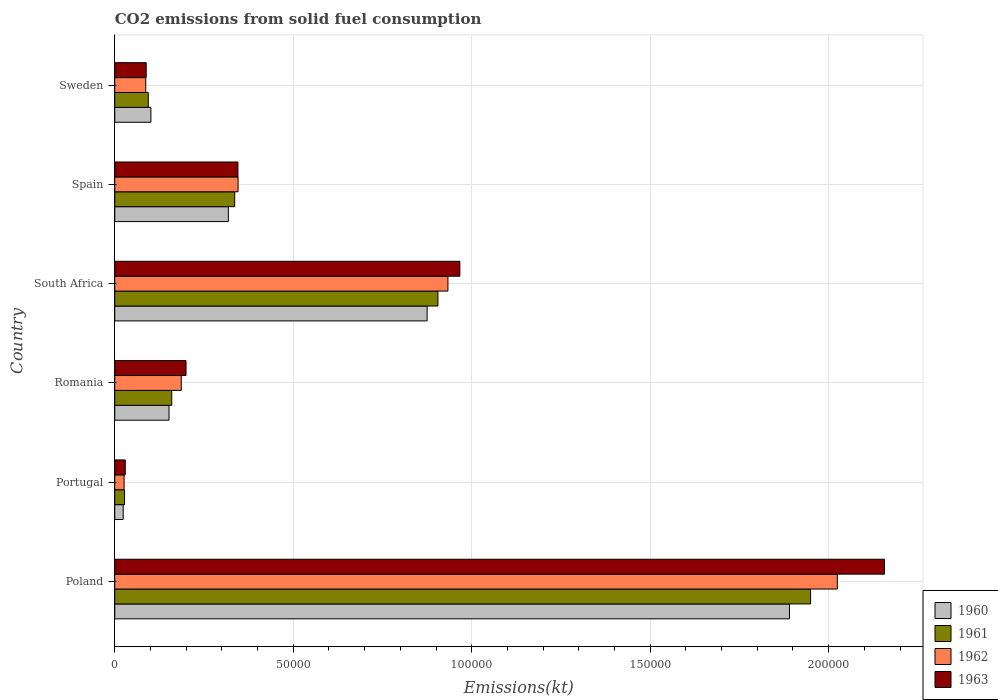How many different coloured bars are there?
Your answer should be very brief. 4. Are the number of bars per tick equal to the number of legend labels?
Make the answer very short. Yes. Are the number of bars on each tick of the Y-axis equal?
Your answer should be compact. Yes. In how many cases, is the number of bars for a given country not equal to the number of legend labels?
Your response must be concise. 0. What is the amount of CO2 emitted in 1963 in South Africa?
Your answer should be very brief. 9.67e+04. Across all countries, what is the maximum amount of CO2 emitted in 1963?
Your answer should be very brief. 2.16e+05. Across all countries, what is the minimum amount of CO2 emitted in 1961?
Make the answer very short. 2742.92. What is the total amount of CO2 emitted in 1963 in the graph?
Ensure brevity in your answer.  3.79e+05. What is the difference between the amount of CO2 emitted in 1960 in Romania and that in South Africa?
Provide a succinct answer. -7.23e+04. What is the difference between the amount of CO2 emitted in 1960 in Portugal and the amount of CO2 emitted in 1961 in Sweden?
Your answer should be very brief. -7029.64. What is the average amount of CO2 emitted in 1963 per country?
Your response must be concise. 6.31e+04. What is the difference between the amount of CO2 emitted in 1961 and amount of CO2 emitted in 1963 in Portugal?
Provide a succinct answer. -201.68. In how many countries, is the amount of CO2 emitted in 1961 greater than 50000 kt?
Offer a terse response. 2. What is the ratio of the amount of CO2 emitted in 1960 in Romania to that in South Africa?
Your answer should be compact. 0.17. Is the difference between the amount of CO2 emitted in 1961 in Portugal and Romania greater than the difference between the amount of CO2 emitted in 1963 in Portugal and Romania?
Your answer should be compact. Yes. What is the difference between the highest and the second highest amount of CO2 emitted in 1963?
Offer a terse response. 1.19e+05. What is the difference between the highest and the lowest amount of CO2 emitted in 1962?
Your answer should be very brief. 2.00e+05. In how many countries, is the amount of CO2 emitted in 1960 greater than the average amount of CO2 emitted in 1960 taken over all countries?
Provide a succinct answer. 2. What does the 2nd bar from the top in South Africa represents?
Keep it short and to the point. 1962. How many bars are there?
Make the answer very short. 24. How many countries are there in the graph?
Make the answer very short. 6. Are the values on the major ticks of X-axis written in scientific E-notation?
Make the answer very short. No. Does the graph contain grids?
Ensure brevity in your answer.  Yes. How many legend labels are there?
Keep it short and to the point. 4. What is the title of the graph?
Provide a succinct answer. CO2 emissions from solid fuel consumption. Does "1986" appear as one of the legend labels in the graph?
Your answer should be compact. No. What is the label or title of the X-axis?
Provide a succinct answer. Emissions(kt). What is the label or title of the Y-axis?
Offer a terse response. Country. What is the Emissions(kt) of 1960 in Poland?
Your answer should be compact. 1.89e+05. What is the Emissions(kt) of 1961 in Poland?
Keep it short and to the point. 1.95e+05. What is the Emissions(kt) in 1962 in Poland?
Make the answer very short. 2.02e+05. What is the Emissions(kt) of 1963 in Poland?
Make the answer very short. 2.16e+05. What is the Emissions(kt) in 1960 in Portugal?
Give a very brief answer. 2365.22. What is the Emissions(kt) of 1961 in Portugal?
Make the answer very short. 2742.92. What is the Emissions(kt) of 1962 in Portugal?
Offer a terse response. 2610.9. What is the Emissions(kt) of 1963 in Portugal?
Offer a terse response. 2944.6. What is the Emissions(kt) of 1960 in Romania?
Make the answer very short. 1.52e+04. What is the Emissions(kt) in 1961 in Romania?
Your answer should be very brief. 1.60e+04. What is the Emissions(kt) of 1962 in Romania?
Your answer should be compact. 1.86e+04. What is the Emissions(kt) of 1963 in Romania?
Keep it short and to the point. 2.00e+04. What is the Emissions(kt) of 1960 in South Africa?
Ensure brevity in your answer.  8.75e+04. What is the Emissions(kt) of 1961 in South Africa?
Your answer should be very brief. 9.05e+04. What is the Emissions(kt) of 1962 in South Africa?
Your answer should be very brief. 9.33e+04. What is the Emissions(kt) of 1963 in South Africa?
Your answer should be very brief. 9.67e+04. What is the Emissions(kt) of 1960 in Spain?
Keep it short and to the point. 3.18e+04. What is the Emissions(kt) of 1961 in Spain?
Offer a terse response. 3.36e+04. What is the Emissions(kt) in 1962 in Spain?
Offer a very short reply. 3.45e+04. What is the Emissions(kt) in 1963 in Spain?
Make the answer very short. 3.45e+04. What is the Emissions(kt) of 1960 in Sweden?
Offer a terse response. 1.01e+04. What is the Emissions(kt) of 1961 in Sweden?
Your response must be concise. 9394.85. What is the Emissions(kt) of 1962 in Sweden?
Give a very brief answer. 8683.46. What is the Emissions(kt) in 1963 in Sweden?
Your response must be concise. 8808.13. Across all countries, what is the maximum Emissions(kt) in 1960?
Provide a succinct answer. 1.89e+05. Across all countries, what is the maximum Emissions(kt) of 1961?
Your answer should be compact. 1.95e+05. Across all countries, what is the maximum Emissions(kt) in 1962?
Ensure brevity in your answer.  2.02e+05. Across all countries, what is the maximum Emissions(kt) in 1963?
Keep it short and to the point. 2.16e+05. Across all countries, what is the minimum Emissions(kt) of 1960?
Keep it short and to the point. 2365.22. Across all countries, what is the minimum Emissions(kt) of 1961?
Give a very brief answer. 2742.92. Across all countries, what is the minimum Emissions(kt) of 1962?
Your answer should be compact. 2610.9. Across all countries, what is the minimum Emissions(kt) in 1963?
Keep it short and to the point. 2944.6. What is the total Emissions(kt) of 1960 in the graph?
Provide a succinct answer. 3.36e+05. What is the total Emissions(kt) in 1961 in the graph?
Give a very brief answer. 3.47e+05. What is the total Emissions(kt) of 1962 in the graph?
Your answer should be compact. 3.60e+05. What is the total Emissions(kt) of 1963 in the graph?
Offer a terse response. 3.79e+05. What is the difference between the Emissions(kt) in 1960 in Poland and that in Portugal?
Make the answer very short. 1.87e+05. What is the difference between the Emissions(kt) of 1961 in Poland and that in Portugal?
Your response must be concise. 1.92e+05. What is the difference between the Emissions(kt) of 1962 in Poland and that in Portugal?
Give a very brief answer. 2.00e+05. What is the difference between the Emissions(kt) in 1963 in Poland and that in Portugal?
Keep it short and to the point. 2.13e+05. What is the difference between the Emissions(kt) of 1960 in Poland and that in Romania?
Provide a short and direct response. 1.74e+05. What is the difference between the Emissions(kt) of 1961 in Poland and that in Romania?
Offer a terse response. 1.79e+05. What is the difference between the Emissions(kt) in 1962 in Poland and that in Romania?
Offer a very short reply. 1.84e+05. What is the difference between the Emissions(kt) in 1963 in Poland and that in Romania?
Offer a terse response. 1.96e+05. What is the difference between the Emissions(kt) in 1960 in Poland and that in South Africa?
Your answer should be compact. 1.02e+05. What is the difference between the Emissions(kt) of 1961 in Poland and that in South Africa?
Provide a short and direct response. 1.04e+05. What is the difference between the Emissions(kt) of 1962 in Poland and that in South Africa?
Your answer should be compact. 1.09e+05. What is the difference between the Emissions(kt) in 1963 in Poland and that in South Africa?
Provide a short and direct response. 1.19e+05. What is the difference between the Emissions(kt) in 1960 in Poland and that in Spain?
Provide a short and direct response. 1.57e+05. What is the difference between the Emissions(kt) in 1961 in Poland and that in Spain?
Offer a very short reply. 1.61e+05. What is the difference between the Emissions(kt) of 1962 in Poland and that in Spain?
Ensure brevity in your answer.  1.68e+05. What is the difference between the Emissions(kt) of 1963 in Poland and that in Spain?
Ensure brevity in your answer.  1.81e+05. What is the difference between the Emissions(kt) of 1960 in Poland and that in Sweden?
Give a very brief answer. 1.79e+05. What is the difference between the Emissions(kt) of 1961 in Poland and that in Sweden?
Provide a succinct answer. 1.86e+05. What is the difference between the Emissions(kt) in 1962 in Poland and that in Sweden?
Offer a terse response. 1.94e+05. What is the difference between the Emissions(kt) in 1963 in Poland and that in Sweden?
Keep it short and to the point. 2.07e+05. What is the difference between the Emissions(kt) in 1960 in Portugal and that in Romania?
Keep it short and to the point. -1.28e+04. What is the difference between the Emissions(kt) of 1961 in Portugal and that in Romania?
Keep it short and to the point. -1.32e+04. What is the difference between the Emissions(kt) in 1962 in Portugal and that in Romania?
Make the answer very short. -1.60e+04. What is the difference between the Emissions(kt) of 1963 in Portugal and that in Romania?
Your answer should be very brief. -1.70e+04. What is the difference between the Emissions(kt) in 1960 in Portugal and that in South Africa?
Give a very brief answer. -8.51e+04. What is the difference between the Emissions(kt) of 1961 in Portugal and that in South Africa?
Give a very brief answer. -8.78e+04. What is the difference between the Emissions(kt) of 1962 in Portugal and that in South Africa?
Give a very brief answer. -9.07e+04. What is the difference between the Emissions(kt) of 1963 in Portugal and that in South Africa?
Provide a succinct answer. -9.37e+04. What is the difference between the Emissions(kt) in 1960 in Portugal and that in Spain?
Offer a very short reply. -2.95e+04. What is the difference between the Emissions(kt) in 1961 in Portugal and that in Spain?
Keep it short and to the point. -3.09e+04. What is the difference between the Emissions(kt) in 1962 in Portugal and that in Spain?
Ensure brevity in your answer.  -3.19e+04. What is the difference between the Emissions(kt) in 1963 in Portugal and that in Spain?
Provide a short and direct response. -3.16e+04. What is the difference between the Emissions(kt) in 1960 in Portugal and that in Sweden?
Your response must be concise. -7759.37. What is the difference between the Emissions(kt) in 1961 in Portugal and that in Sweden?
Offer a very short reply. -6651.94. What is the difference between the Emissions(kt) in 1962 in Portugal and that in Sweden?
Your response must be concise. -6072.55. What is the difference between the Emissions(kt) in 1963 in Portugal and that in Sweden?
Ensure brevity in your answer.  -5863.53. What is the difference between the Emissions(kt) in 1960 in Romania and that in South Africa?
Keep it short and to the point. -7.23e+04. What is the difference between the Emissions(kt) in 1961 in Romania and that in South Africa?
Your answer should be compact. -7.46e+04. What is the difference between the Emissions(kt) in 1962 in Romania and that in South Africa?
Offer a very short reply. -7.47e+04. What is the difference between the Emissions(kt) of 1963 in Romania and that in South Africa?
Provide a succinct answer. -7.67e+04. What is the difference between the Emissions(kt) of 1960 in Romania and that in Spain?
Keep it short and to the point. -1.66e+04. What is the difference between the Emissions(kt) in 1961 in Romania and that in Spain?
Your answer should be very brief. -1.76e+04. What is the difference between the Emissions(kt) of 1962 in Romania and that in Spain?
Your answer should be compact. -1.59e+04. What is the difference between the Emissions(kt) of 1963 in Romania and that in Spain?
Give a very brief answer. -1.45e+04. What is the difference between the Emissions(kt) of 1960 in Romania and that in Sweden?
Provide a succinct answer. 5078.8. What is the difference between the Emissions(kt) in 1961 in Romania and that in Sweden?
Keep it short and to the point. 6574.93. What is the difference between the Emissions(kt) in 1962 in Romania and that in Sweden?
Keep it short and to the point. 9948.57. What is the difference between the Emissions(kt) in 1963 in Romania and that in Sweden?
Keep it short and to the point. 1.12e+04. What is the difference between the Emissions(kt) of 1960 in South Africa and that in Spain?
Provide a succinct answer. 5.57e+04. What is the difference between the Emissions(kt) in 1961 in South Africa and that in Spain?
Provide a short and direct response. 5.69e+04. What is the difference between the Emissions(kt) in 1962 in South Africa and that in Spain?
Provide a short and direct response. 5.88e+04. What is the difference between the Emissions(kt) in 1963 in South Africa and that in Spain?
Offer a terse response. 6.22e+04. What is the difference between the Emissions(kt) in 1960 in South Africa and that in Sweden?
Provide a short and direct response. 7.74e+04. What is the difference between the Emissions(kt) in 1961 in South Africa and that in Sweden?
Ensure brevity in your answer.  8.12e+04. What is the difference between the Emissions(kt) of 1962 in South Africa and that in Sweden?
Make the answer very short. 8.47e+04. What is the difference between the Emissions(kt) in 1963 in South Africa and that in Sweden?
Your response must be concise. 8.79e+04. What is the difference between the Emissions(kt) of 1960 in Spain and that in Sweden?
Ensure brevity in your answer.  2.17e+04. What is the difference between the Emissions(kt) of 1961 in Spain and that in Sweden?
Your response must be concise. 2.42e+04. What is the difference between the Emissions(kt) in 1962 in Spain and that in Sweden?
Ensure brevity in your answer.  2.59e+04. What is the difference between the Emissions(kt) of 1963 in Spain and that in Sweden?
Your answer should be compact. 2.57e+04. What is the difference between the Emissions(kt) of 1960 in Poland and the Emissions(kt) of 1961 in Portugal?
Your response must be concise. 1.86e+05. What is the difference between the Emissions(kt) of 1960 in Poland and the Emissions(kt) of 1962 in Portugal?
Keep it short and to the point. 1.86e+05. What is the difference between the Emissions(kt) in 1960 in Poland and the Emissions(kt) in 1963 in Portugal?
Ensure brevity in your answer.  1.86e+05. What is the difference between the Emissions(kt) of 1961 in Poland and the Emissions(kt) of 1962 in Portugal?
Provide a short and direct response. 1.92e+05. What is the difference between the Emissions(kt) in 1961 in Poland and the Emissions(kt) in 1963 in Portugal?
Give a very brief answer. 1.92e+05. What is the difference between the Emissions(kt) of 1962 in Poland and the Emissions(kt) of 1963 in Portugal?
Provide a short and direct response. 1.99e+05. What is the difference between the Emissions(kt) of 1960 in Poland and the Emissions(kt) of 1961 in Romania?
Your answer should be very brief. 1.73e+05. What is the difference between the Emissions(kt) of 1960 in Poland and the Emissions(kt) of 1962 in Romania?
Offer a very short reply. 1.70e+05. What is the difference between the Emissions(kt) of 1960 in Poland and the Emissions(kt) of 1963 in Romania?
Ensure brevity in your answer.  1.69e+05. What is the difference between the Emissions(kt) in 1961 in Poland and the Emissions(kt) in 1962 in Romania?
Ensure brevity in your answer.  1.76e+05. What is the difference between the Emissions(kt) of 1961 in Poland and the Emissions(kt) of 1963 in Romania?
Provide a succinct answer. 1.75e+05. What is the difference between the Emissions(kt) in 1962 in Poland and the Emissions(kt) in 1963 in Romania?
Your response must be concise. 1.82e+05. What is the difference between the Emissions(kt) in 1960 in Poland and the Emissions(kt) in 1961 in South Africa?
Your response must be concise. 9.85e+04. What is the difference between the Emissions(kt) in 1960 in Poland and the Emissions(kt) in 1962 in South Africa?
Your response must be concise. 9.57e+04. What is the difference between the Emissions(kt) in 1960 in Poland and the Emissions(kt) in 1963 in South Africa?
Provide a succinct answer. 9.23e+04. What is the difference between the Emissions(kt) in 1961 in Poland and the Emissions(kt) in 1962 in South Africa?
Make the answer very short. 1.02e+05. What is the difference between the Emissions(kt) of 1961 in Poland and the Emissions(kt) of 1963 in South Africa?
Keep it short and to the point. 9.83e+04. What is the difference between the Emissions(kt) of 1962 in Poland and the Emissions(kt) of 1963 in South Africa?
Provide a short and direct response. 1.06e+05. What is the difference between the Emissions(kt) of 1960 in Poland and the Emissions(kt) of 1961 in Spain?
Provide a short and direct response. 1.55e+05. What is the difference between the Emissions(kt) of 1960 in Poland and the Emissions(kt) of 1962 in Spain?
Keep it short and to the point. 1.54e+05. What is the difference between the Emissions(kt) of 1960 in Poland and the Emissions(kt) of 1963 in Spain?
Give a very brief answer. 1.55e+05. What is the difference between the Emissions(kt) of 1961 in Poland and the Emissions(kt) of 1962 in Spain?
Give a very brief answer. 1.60e+05. What is the difference between the Emissions(kt) of 1961 in Poland and the Emissions(kt) of 1963 in Spain?
Your answer should be compact. 1.60e+05. What is the difference between the Emissions(kt) of 1962 in Poland and the Emissions(kt) of 1963 in Spain?
Your answer should be very brief. 1.68e+05. What is the difference between the Emissions(kt) of 1960 in Poland and the Emissions(kt) of 1961 in Sweden?
Give a very brief answer. 1.80e+05. What is the difference between the Emissions(kt) of 1960 in Poland and the Emissions(kt) of 1962 in Sweden?
Provide a short and direct response. 1.80e+05. What is the difference between the Emissions(kt) of 1960 in Poland and the Emissions(kt) of 1963 in Sweden?
Your answer should be compact. 1.80e+05. What is the difference between the Emissions(kt) of 1961 in Poland and the Emissions(kt) of 1962 in Sweden?
Ensure brevity in your answer.  1.86e+05. What is the difference between the Emissions(kt) in 1961 in Poland and the Emissions(kt) in 1963 in Sweden?
Give a very brief answer. 1.86e+05. What is the difference between the Emissions(kt) of 1962 in Poland and the Emissions(kt) of 1963 in Sweden?
Give a very brief answer. 1.94e+05. What is the difference between the Emissions(kt) of 1960 in Portugal and the Emissions(kt) of 1961 in Romania?
Make the answer very short. -1.36e+04. What is the difference between the Emissions(kt) in 1960 in Portugal and the Emissions(kt) in 1962 in Romania?
Your answer should be very brief. -1.63e+04. What is the difference between the Emissions(kt) of 1960 in Portugal and the Emissions(kt) of 1963 in Romania?
Offer a terse response. -1.76e+04. What is the difference between the Emissions(kt) in 1961 in Portugal and the Emissions(kt) in 1962 in Romania?
Offer a very short reply. -1.59e+04. What is the difference between the Emissions(kt) of 1961 in Portugal and the Emissions(kt) of 1963 in Romania?
Offer a terse response. -1.72e+04. What is the difference between the Emissions(kt) in 1962 in Portugal and the Emissions(kt) in 1963 in Romania?
Your answer should be compact. -1.74e+04. What is the difference between the Emissions(kt) in 1960 in Portugal and the Emissions(kt) in 1961 in South Africa?
Give a very brief answer. -8.82e+04. What is the difference between the Emissions(kt) of 1960 in Portugal and the Emissions(kt) of 1962 in South Africa?
Keep it short and to the point. -9.10e+04. What is the difference between the Emissions(kt) of 1960 in Portugal and the Emissions(kt) of 1963 in South Africa?
Ensure brevity in your answer.  -9.43e+04. What is the difference between the Emissions(kt) of 1961 in Portugal and the Emissions(kt) of 1962 in South Africa?
Give a very brief answer. -9.06e+04. What is the difference between the Emissions(kt) in 1961 in Portugal and the Emissions(kt) in 1963 in South Africa?
Make the answer very short. -9.39e+04. What is the difference between the Emissions(kt) of 1962 in Portugal and the Emissions(kt) of 1963 in South Africa?
Offer a terse response. -9.41e+04. What is the difference between the Emissions(kt) of 1960 in Portugal and the Emissions(kt) of 1961 in Spain?
Give a very brief answer. -3.12e+04. What is the difference between the Emissions(kt) in 1960 in Portugal and the Emissions(kt) in 1962 in Spain?
Provide a short and direct response. -3.22e+04. What is the difference between the Emissions(kt) in 1960 in Portugal and the Emissions(kt) in 1963 in Spain?
Your response must be concise. -3.21e+04. What is the difference between the Emissions(kt) in 1961 in Portugal and the Emissions(kt) in 1962 in Spain?
Give a very brief answer. -3.18e+04. What is the difference between the Emissions(kt) of 1961 in Portugal and the Emissions(kt) of 1963 in Spain?
Ensure brevity in your answer.  -3.18e+04. What is the difference between the Emissions(kt) in 1962 in Portugal and the Emissions(kt) in 1963 in Spain?
Offer a terse response. -3.19e+04. What is the difference between the Emissions(kt) in 1960 in Portugal and the Emissions(kt) in 1961 in Sweden?
Provide a short and direct response. -7029.64. What is the difference between the Emissions(kt) of 1960 in Portugal and the Emissions(kt) of 1962 in Sweden?
Provide a short and direct response. -6318.24. What is the difference between the Emissions(kt) in 1960 in Portugal and the Emissions(kt) in 1963 in Sweden?
Your response must be concise. -6442.92. What is the difference between the Emissions(kt) of 1961 in Portugal and the Emissions(kt) of 1962 in Sweden?
Your response must be concise. -5940.54. What is the difference between the Emissions(kt) in 1961 in Portugal and the Emissions(kt) in 1963 in Sweden?
Your answer should be compact. -6065.22. What is the difference between the Emissions(kt) of 1962 in Portugal and the Emissions(kt) of 1963 in Sweden?
Offer a terse response. -6197.23. What is the difference between the Emissions(kt) of 1960 in Romania and the Emissions(kt) of 1961 in South Africa?
Your response must be concise. -7.53e+04. What is the difference between the Emissions(kt) of 1960 in Romania and the Emissions(kt) of 1962 in South Africa?
Make the answer very short. -7.81e+04. What is the difference between the Emissions(kt) in 1960 in Romania and the Emissions(kt) in 1963 in South Africa?
Your response must be concise. -8.15e+04. What is the difference between the Emissions(kt) in 1961 in Romania and the Emissions(kt) in 1962 in South Africa?
Keep it short and to the point. -7.74e+04. What is the difference between the Emissions(kt) in 1961 in Romania and the Emissions(kt) in 1963 in South Africa?
Your response must be concise. -8.07e+04. What is the difference between the Emissions(kt) in 1962 in Romania and the Emissions(kt) in 1963 in South Africa?
Make the answer very short. -7.80e+04. What is the difference between the Emissions(kt) in 1960 in Romania and the Emissions(kt) in 1961 in Spain?
Provide a succinct answer. -1.84e+04. What is the difference between the Emissions(kt) of 1960 in Romania and the Emissions(kt) of 1962 in Spain?
Your answer should be compact. -1.93e+04. What is the difference between the Emissions(kt) in 1960 in Romania and the Emissions(kt) in 1963 in Spain?
Keep it short and to the point. -1.93e+04. What is the difference between the Emissions(kt) in 1961 in Romania and the Emissions(kt) in 1962 in Spain?
Provide a short and direct response. -1.86e+04. What is the difference between the Emissions(kt) of 1961 in Romania and the Emissions(kt) of 1963 in Spain?
Your answer should be compact. -1.85e+04. What is the difference between the Emissions(kt) in 1962 in Romania and the Emissions(kt) in 1963 in Spain?
Your response must be concise. -1.59e+04. What is the difference between the Emissions(kt) in 1960 in Romania and the Emissions(kt) in 1961 in Sweden?
Provide a short and direct response. 5808.53. What is the difference between the Emissions(kt) in 1960 in Romania and the Emissions(kt) in 1962 in Sweden?
Your answer should be very brief. 6519.93. What is the difference between the Emissions(kt) in 1960 in Romania and the Emissions(kt) in 1963 in Sweden?
Your response must be concise. 6395.25. What is the difference between the Emissions(kt) in 1961 in Romania and the Emissions(kt) in 1962 in Sweden?
Give a very brief answer. 7286.33. What is the difference between the Emissions(kt) of 1961 in Romania and the Emissions(kt) of 1963 in Sweden?
Your answer should be compact. 7161.65. What is the difference between the Emissions(kt) of 1962 in Romania and the Emissions(kt) of 1963 in Sweden?
Provide a short and direct response. 9823.89. What is the difference between the Emissions(kt) in 1960 in South Africa and the Emissions(kt) in 1961 in Spain?
Your answer should be very brief. 5.39e+04. What is the difference between the Emissions(kt) in 1960 in South Africa and the Emissions(kt) in 1962 in Spain?
Make the answer very short. 5.30e+04. What is the difference between the Emissions(kt) in 1960 in South Africa and the Emissions(kt) in 1963 in Spain?
Keep it short and to the point. 5.30e+04. What is the difference between the Emissions(kt) in 1961 in South Africa and the Emissions(kt) in 1962 in Spain?
Offer a terse response. 5.60e+04. What is the difference between the Emissions(kt) of 1961 in South Africa and the Emissions(kt) of 1963 in Spain?
Give a very brief answer. 5.60e+04. What is the difference between the Emissions(kt) in 1962 in South Africa and the Emissions(kt) in 1963 in Spain?
Keep it short and to the point. 5.88e+04. What is the difference between the Emissions(kt) of 1960 in South Africa and the Emissions(kt) of 1961 in Sweden?
Your answer should be very brief. 7.81e+04. What is the difference between the Emissions(kt) in 1960 in South Africa and the Emissions(kt) in 1962 in Sweden?
Offer a terse response. 7.88e+04. What is the difference between the Emissions(kt) in 1960 in South Africa and the Emissions(kt) in 1963 in Sweden?
Provide a short and direct response. 7.87e+04. What is the difference between the Emissions(kt) in 1961 in South Africa and the Emissions(kt) in 1962 in Sweden?
Provide a succinct answer. 8.19e+04. What is the difference between the Emissions(kt) in 1961 in South Africa and the Emissions(kt) in 1963 in Sweden?
Give a very brief answer. 8.17e+04. What is the difference between the Emissions(kt) of 1962 in South Africa and the Emissions(kt) of 1963 in Sweden?
Provide a short and direct response. 8.45e+04. What is the difference between the Emissions(kt) in 1960 in Spain and the Emissions(kt) in 1961 in Sweden?
Give a very brief answer. 2.24e+04. What is the difference between the Emissions(kt) of 1960 in Spain and the Emissions(kt) of 1962 in Sweden?
Give a very brief answer. 2.31e+04. What is the difference between the Emissions(kt) in 1960 in Spain and the Emissions(kt) in 1963 in Sweden?
Ensure brevity in your answer.  2.30e+04. What is the difference between the Emissions(kt) in 1961 in Spain and the Emissions(kt) in 1962 in Sweden?
Make the answer very short. 2.49e+04. What is the difference between the Emissions(kt) in 1961 in Spain and the Emissions(kt) in 1963 in Sweden?
Keep it short and to the point. 2.48e+04. What is the difference between the Emissions(kt) of 1962 in Spain and the Emissions(kt) of 1963 in Sweden?
Offer a terse response. 2.57e+04. What is the average Emissions(kt) in 1960 per country?
Offer a terse response. 5.60e+04. What is the average Emissions(kt) of 1961 per country?
Give a very brief answer. 5.79e+04. What is the average Emissions(kt) of 1962 per country?
Keep it short and to the point. 6.00e+04. What is the average Emissions(kt) in 1963 per country?
Your answer should be compact. 6.31e+04. What is the difference between the Emissions(kt) in 1960 and Emissions(kt) in 1961 in Poland?
Ensure brevity in your answer.  -5918.54. What is the difference between the Emissions(kt) of 1960 and Emissions(kt) of 1962 in Poland?
Ensure brevity in your answer.  -1.34e+04. What is the difference between the Emissions(kt) of 1960 and Emissions(kt) of 1963 in Poland?
Give a very brief answer. -2.66e+04. What is the difference between the Emissions(kt) of 1961 and Emissions(kt) of 1962 in Poland?
Provide a short and direct response. -7484.35. What is the difference between the Emissions(kt) of 1961 and Emissions(kt) of 1963 in Poland?
Offer a terse response. -2.07e+04. What is the difference between the Emissions(kt) in 1962 and Emissions(kt) in 1963 in Poland?
Your answer should be very brief. -1.32e+04. What is the difference between the Emissions(kt) of 1960 and Emissions(kt) of 1961 in Portugal?
Your answer should be very brief. -377.7. What is the difference between the Emissions(kt) of 1960 and Emissions(kt) of 1962 in Portugal?
Give a very brief answer. -245.69. What is the difference between the Emissions(kt) of 1960 and Emissions(kt) of 1963 in Portugal?
Ensure brevity in your answer.  -579.39. What is the difference between the Emissions(kt) of 1961 and Emissions(kt) of 1962 in Portugal?
Provide a succinct answer. 132.01. What is the difference between the Emissions(kt) of 1961 and Emissions(kt) of 1963 in Portugal?
Provide a short and direct response. -201.69. What is the difference between the Emissions(kt) of 1962 and Emissions(kt) of 1963 in Portugal?
Give a very brief answer. -333.7. What is the difference between the Emissions(kt) in 1960 and Emissions(kt) in 1961 in Romania?
Provide a succinct answer. -766.4. What is the difference between the Emissions(kt) of 1960 and Emissions(kt) of 1962 in Romania?
Keep it short and to the point. -3428.64. What is the difference between the Emissions(kt) in 1960 and Emissions(kt) in 1963 in Romania?
Ensure brevity in your answer.  -4763.43. What is the difference between the Emissions(kt) in 1961 and Emissions(kt) in 1962 in Romania?
Give a very brief answer. -2662.24. What is the difference between the Emissions(kt) of 1961 and Emissions(kt) of 1963 in Romania?
Give a very brief answer. -3997.03. What is the difference between the Emissions(kt) in 1962 and Emissions(kt) in 1963 in Romania?
Offer a very short reply. -1334.79. What is the difference between the Emissions(kt) of 1960 and Emissions(kt) of 1961 in South Africa?
Provide a short and direct response. -3032.61. What is the difference between the Emissions(kt) of 1960 and Emissions(kt) of 1962 in South Africa?
Offer a terse response. -5823.2. What is the difference between the Emissions(kt) in 1960 and Emissions(kt) in 1963 in South Africa?
Your answer should be compact. -9167.5. What is the difference between the Emissions(kt) in 1961 and Emissions(kt) in 1962 in South Africa?
Keep it short and to the point. -2790.59. What is the difference between the Emissions(kt) of 1961 and Emissions(kt) of 1963 in South Africa?
Ensure brevity in your answer.  -6134.89. What is the difference between the Emissions(kt) in 1962 and Emissions(kt) in 1963 in South Africa?
Your answer should be compact. -3344.3. What is the difference between the Emissions(kt) in 1960 and Emissions(kt) in 1961 in Spain?
Make the answer very short. -1782.16. What is the difference between the Emissions(kt) of 1960 and Emissions(kt) of 1962 in Spain?
Your answer should be very brief. -2720.91. What is the difference between the Emissions(kt) in 1960 and Emissions(kt) in 1963 in Spain?
Offer a terse response. -2684.24. What is the difference between the Emissions(kt) in 1961 and Emissions(kt) in 1962 in Spain?
Offer a very short reply. -938.75. What is the difference between the Emissions(kt) of 1961 and Emissions(kt) of 1963 in Spain?
Your answer should be compact. -902.08. What is the difference between the Emissions(kt) of 1962 and Emissions(kt) of 1963 in Spain?
Your answer should be compact. 36.67. What is the difference between the Emissions(kt) in 1960 and Emissions(kt) in 1961 in Sweden?
Keep it short and to the point. 729.73. What is the difference between the Emissions(kt) of 1960 and Emissions(kt) of 1962 in Sweden?
Offer a very short reply. 1441.13. What is the difference between the Emissions(kt) in 1960 and Emissions(kt) in 1963 in Sweden?
Give a very brief answer. 1316.45. What is the difference between the Emissions(kt) in 1961 and Emissions(kt) in 1962 in Sweden?
Give a very brief answer. 711.4. What is the difference between the Emissions(kt) of 1961 and Emissions(kt) of 1963 in Sweden?
Ensure brevity in your answer.  586.72. What is the difference between the Emissions(kt) of 1962 and Emissions(kt) of 1963 in Sweden?
Your answer should be compact. -124.68. What is the ratio of the Emissions(kt) of 1960 in Poland to that in Portugal?
Ensure brevity in your answer.  79.92. What is the ratio of the Emissions(kt) in 1961 in Poland to that in Portugal?
Your answer should be very brief. 71.07. What is the ratio of the Emissions(kt) in 1962 in Poland to that in Portugal?
Provide a short and direct response. 77.53. What is the ratio of the Emissions(kt) in 1963 in Poland to that in Portugal?
Offer a terse response. 73.24. What is the ratio of the Emissions(kt) in 1960 in Poland to that in Romania?
Provide a short and direct response. 12.43. What is the ratio of the Emissions(kt) of 1961 in Poland to that in Romania?
Offer a very short reply. 12.21. What is the ratio of the Emissions(kt) in 1962 in Poland to that in Romania?
Ensure brevity in your answer.  10.86. What is the ratio of the Emissions(kt) of 1963 in Poland to that in Romania?
Your answer should be compact. 10.8. What is the ratio of the Emissions(kt) in 1960 in Poland to that in South Africa?
Offer a terse response. 2.16. What is the ratio of the Emissions(kt) of 1961 in Poland to that in South Africa?
Your response must be concise. 2.15. What is the ratio of the Emissions(kt) of 1962 in Poland to that in South Africa?
Provide a short and direct response. 2.17. What is the ratio of the Emissions(kt) of 1963 in Poland to that in South Africa?
Offer a very short reply. 2.23. What is the ratio of the Emissions(kt) of 1960 in Poland to that in Spain?
Your response must be concise. 5.94. What is the ratio of the Emissions(kt) of 1961 in Poland to that in Spain?
Your response must be concise. 5.8. What is the ratio of the Emissions(kt) of 1962 in Poland to that in Spain?
Give a very brief answer. 5.86. What is the ratio of the Emissions(kt) in 1963 in Poland to that in Spain?
Offer a very short reply. 6.25. What is the ratio of the Emissions(kt) in 1960 in Poland to that in Sweden?
Offer a terse response. 18.67. What is the ratio of the Emissions(kt) of 1961 in Poland to that in Sweden?
Your answer should be very brief. 20.75. What is the ratio of the Emissions(kt) of 1962 in Poland to that in Sweden?
Your response must be concise. 23.31. What is the ratio of the Emissions(kt) of 1963 in Poland to that in Sweden?
Your response must be concise. 24.48. What is the ratio of the Emissions(kt) of 1960 in Portugal to that in Romania?
Your answer should be very brief. 0.16. What is the ratio of the Emissions(kt) in 1961 in Portugal to that in Romania?
Your answer should be compact. 0.17. What is the ratio of the Emissions(kt) in 1962 in Portugal to that in Romania?
Offer a very short reply. 0.14. What is the ratio of the Emissions(kt) of 1963 in Portugal to that in Romania?
Offer a very short reply. 0.15. What is the ratio of the Emissions(kt) of 1960 in Portugal to that in South Africa?
Give a very brief answer. 0.03. What is the ratio of the Emissions(kt) in 1961 in Portugal to that in South Africa?
Provide a succinct answer. 0.03. What is the ratio of the Emissions(kt) of 1962 in Portugal to that in South Africa?
Give a very brief answer. 0.03. What is the ratio of the Emissions(kt) of 1963 in Portugal to that in South Africa?
Make the answer very short. 0.03. What is the ratio of the Emissions(kt) in 1960 in Portugal to that in Spain?
Provide a succinct answer. 0.07. What is the ratio of the Emissions(kt) in 1961 in Portugal to that in Spain?
Ensure brevity in your answer.  0.08. What is the ratio of the Emissions(kt) of 1962 in Portugal to that in Spain?
Your response must be concise. 0.08. What is the ratio of the Emissions(kt) of 1963 in Portugal to that in Spain?
Your answer should be compact. 0.09. What is the ratio of the Emissions(kt) of 1960 in Portugal to that in Sweden?
Your answer should be compact. 0.23. What is the ratio of the Emissions(kt) of 1961 in Portugal to that in Sweden?
Ensure brevity in your answer.  0.29. What is the ratio of the Emissions(kt) of 1962 in Portugal to that in Sweden?
Your answer should be compact. 0.3. What is the ratio of the Emissions(kt) in 1963 in Portugal to that in Sweden?
Offer a very short reply. 0.33. What is the ratio of the Emissions(kt) of 1960 in Romania to that in South Africa?
Provide a succinct answer. 0.17. What is the ratio of the Emissions(kt) of 1961 in Romania to that in South Africa?
Ensure brevity in your answer.  0.18. What is the ratio of the Emissions(kt) in 1962 in Romania to that in South Africa?
Offer a terse response. 0.2. What is the ratio of the Emissions(kt) of 1963 in Romania to that in South Africa?
Provide a succinct answer. 0.21. What is the ratio of the Emissions(kt) of 1960 in Romania to that in Spain?
Your response must be concise. 0.48. What is the ratio of the Emissions(kt) of 1961 in Romania to that in Spain?
Your answer should be compact. 0.48. What is the ratio of the Emissions(kt) in 1962 in Romania to that in Spain?
Offer a very short reply. 0.54. What is the ratio of the Emissions(kt) of 1963 in Romania to that in Spain?
Your answer should be compact. 0.58. What is the ratio of the Emissions(kt) of 1960 in Romania to that in Sweden?
Your answer should be very brief. 1.5. What is the ratio of the Emissions(kt) of 1961 in Romania to that in Sweden?
Provide a succinct answer. 1.7. What is the ratio of the Emissions(kt) in 1962 in Romania to that in Sweden?
Your response must be concise. 2.15. What is the ratio of the Emissions(kt) in 1963 in Romania to that in Sweden?
Provide a succinct answer. 2.27. What is the ratio of the Emissions(kt) of 1960 in South Africa to that in Spain?
Keep it short and to the point. 2.75. What is the ratio of the Emissions(kt) in 1961 in South Africa to that in Spain?
Provide a succinct answer. 2.69. What is the ratio of the Emissions(kt) in 1962 in South Africa to that in Spain?
Offer a very short reply. 2.7. What is the ratio of the Emissions(kt) in 1963 in South Africa to that in Spain?
Offer a terse response. 2.8. What is the ratio of the Emissions(kt) in 1960 in South Africa to that in Sweden?
Your response must be concise. 8.64. What is the ratio of the Emissions(kt) in 1961 in South Africa to that in Sweden?
Ensure brevity in your answer.  9.64. What is the ratio of the Emissions(kt) of 1962 in South Africa to that in Sweden?
Your response must be concise. 10.75. What is the ratio of the Emissions(kt) of 1963 in South Africa to that in Sweden?
Offer a very short reply. 10.98. What is the ratio of the Emissions(kt) in 1960 in Spain to that in Sweden?
Your response must be concise. 3.14. What is the ratio of the Emissions(kt) of 1961 in Spain to that in Sweden?
Offer a very short reply. 3.58. What is the ratio of the Emissions(kt) in 1962 in Spain to that in Sweden?
Provide a succinct answer. 3.98. What is the ratio of the Emissions(kt) in 1963 in Spain to that in Sweden?
Offer a terse response. 3.92. What is the difference between the highest and the second highest Emissions(kt) in 1960?
Your response must be concise. 1.02e+05. What is the difference between the highest and the second highest Emissions(kt) of 1961?
Your answer should be compact. 1.04e+05. What is the difference between the highest and the second highest Emissions(kt) of 1962?
Keep it short and to the point. 1.09e+05. What is the difference between the highest and the second highest Emissions(kt) in 1963?
Offer a terse response. 1.19e+05. What is the difference between the highest and the lowest Emissions(kt) of 1960?
Make the answer very short. 1.87e+05. What is the difference between the highest and the lowest Emissions(kt) in 1961?
Offer a very short reply. 1.92e+05. What is the difference between the highest and the lowest Emissions(kt) in 1962?
Give a very brief answer. 2.00e+05. What is the difference between the highest and the lowest Emissions(kt) of 1963?
Offer a terse response. 2.13e+05. 